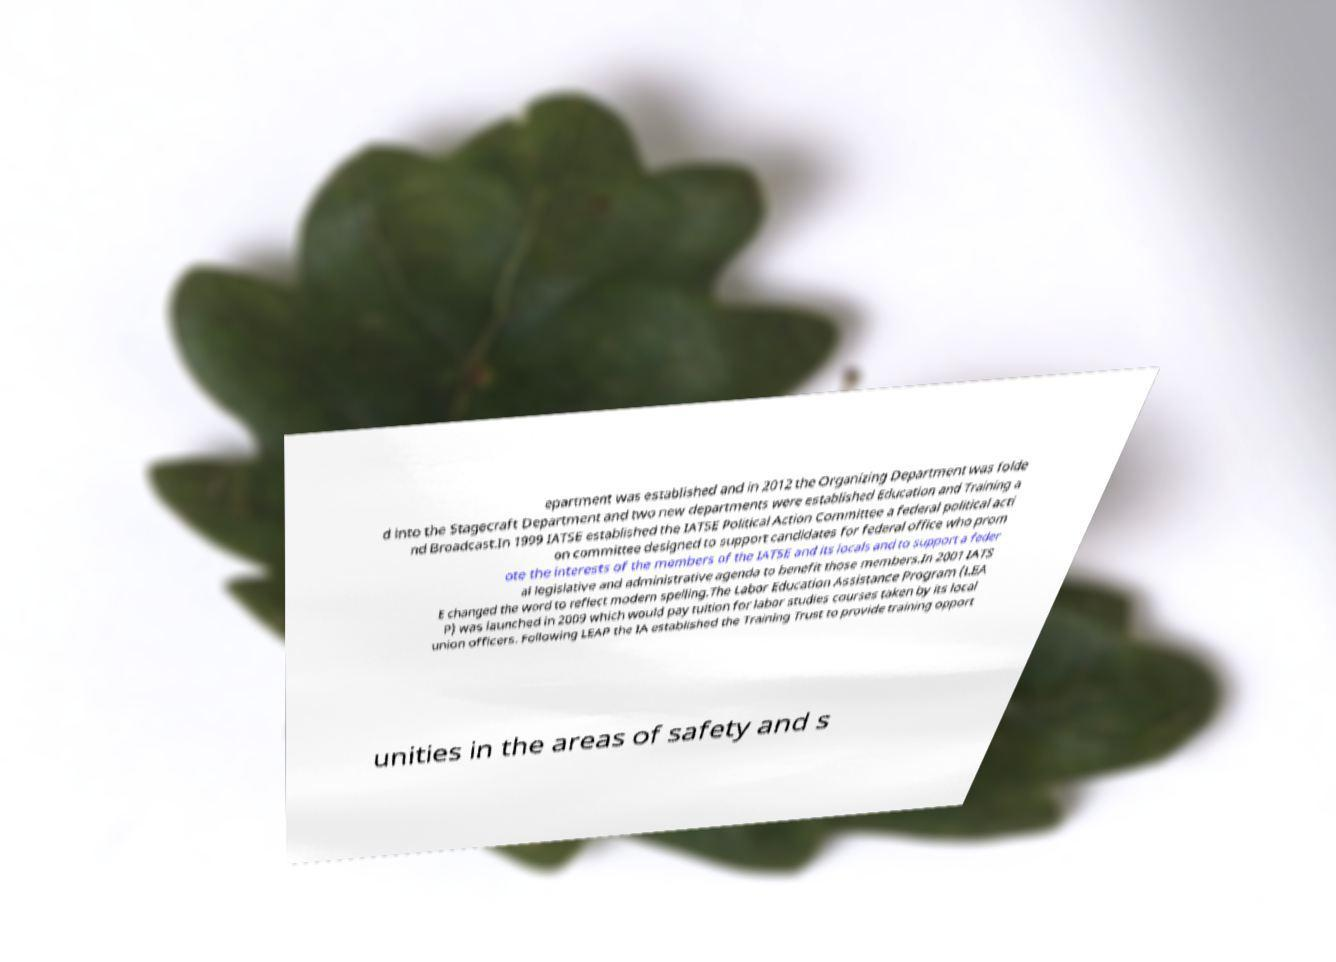For documentation purposes, I need the text within this image transcribed. Could you provide that? epartment was established and in 2012 the Organizing Department was folde d into the Stagecraft Department and two new departments were established Education and Training a nd Broadcast.In 1999 IATSE established the IATSE Political Action Committee a federal political acti on committee designed to support candidates for federal office who prom ote the interests of the members of the IATSE and its locals and to support a feder al legislative and administrative agenda to benefit those members.In 2001 IATS E changed the word to reflect modern spelling.The Labor Education Assistance Program (LEA P) was launched in 2009 which would pay tuition for labor studies courses taken by its local union officers. Following LEAP the IA established the Training Trust to provide training opport unities in the areas of safety and s 